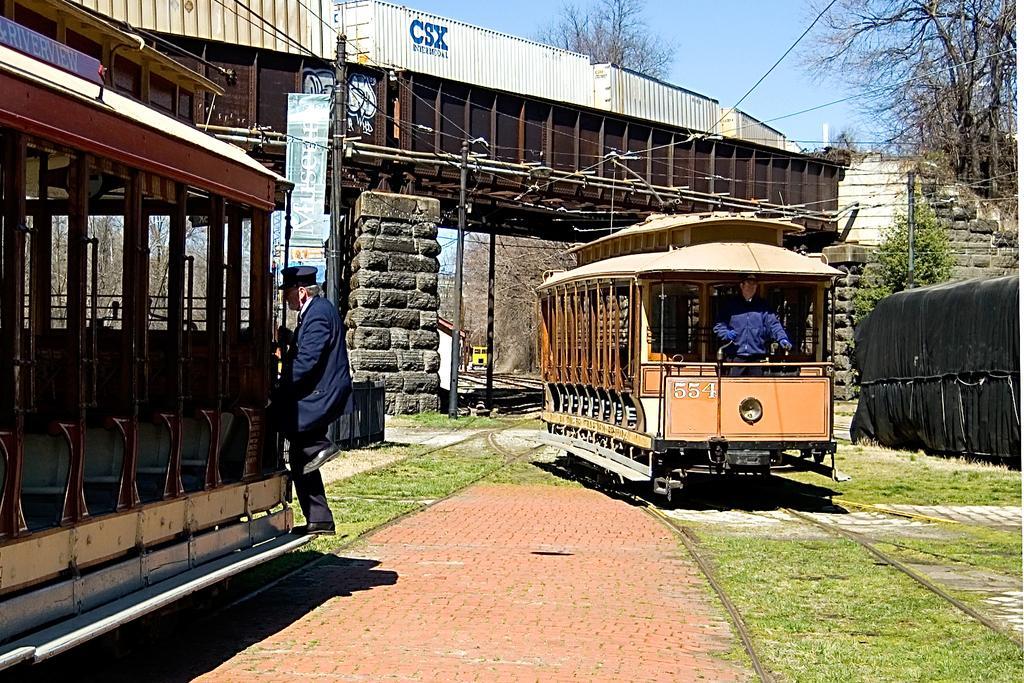Could you give a brief overview of what you see in this image? In this image on the left, there is a man, he wears a suit, shirt, trouser, shoes and cap, he is on the train. In the middle there is a train on that there is a man, in front of that there is a railway track. In the middle there are electric poles, cables, shed, wall, train, trees and sky. 